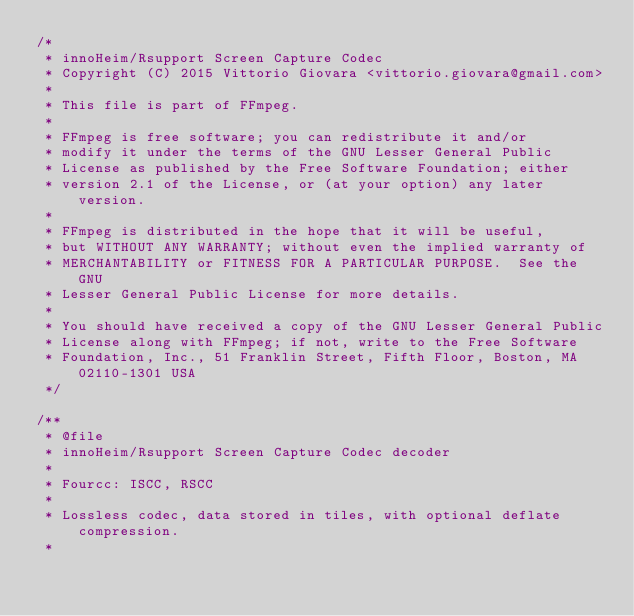<code> <loc_0><loc_0><loc_500><loc_500><_C_>/*
 * innoHeim/Rsupport Screen Capture Codec
 * Copyright (C) 2015 Vittorio Giovara <vittorio.giovara@gmail.com>
 *
 * This file is part of FFmpeg.
 *
 * FFmpeg is free software; you can redistribute it and/or
 * modify it under the terms of the GNU Lesser General Public
 * License as published by the Free Software Foundation; either
 * version 2.1 of the License, or (at your option) any later version.
 *
 * FFmpeg is distributed in the hope that it will be useful,
 * but WITHOUT ANY WARRANTY; without even the implied warranty of
 * MERCHANTABILITY or FITNESS FOR A PARTICULAR PURPOSE.  See the GNU
 * Lesser General Public License for more details.
 *
 * You should have received a copy of the GNU Lesser General Public
 * License along with FFmpeg; if not, write to the Free Software
 * Foundation, Inc., 51 Franklin Street, Fifth Floor, Boston, MA 02110-1301 USA
 */

/**
 * @file
 * innoHeim/Rsupport Screen Capture Codec decoder
 *
 * Fourcc: ISCC, RSCC
 *
 * Lossless codec, data stored in tiles, with optional deflate compression.
 *</code> 